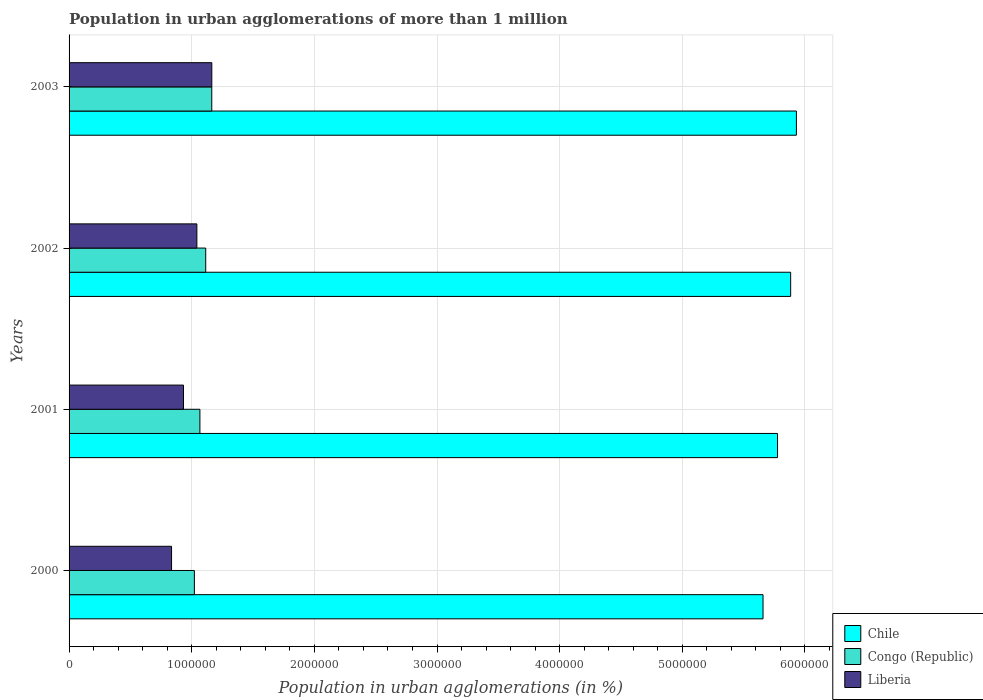How many different coloured bars are there?
Give a very brief answer. 3. Are the number of bars per tick equal to the number of legend labels?
Keep it short and to the point. Yes. Are the number of bars on each tick of the Y-axis equal?
Provide a succinct answer. Yes. How many bars are there on the 2nd tick from the bottom?
Your answer should be very brief. 3. In how many cases, is the number of bars for a given year not equal to the number of legend labels?
Keep it short and to the point. 0. What is the population in urban agglomerations in Congo (Republic) in 2003?
Offer a very short reply. 1.16e+06. Across all years, what is the maximum population in urban agglomerations in Chile?
Give a very brief answer. 5.93e+06. Across all years, what is the minimum population in urban agglomerations in Chile?
Provide a short and direct response. 5.66e+06. In which year was the population in urban agglomerations in Chile minimum?
Offer a terse response. 2000. What is the total population in urban agglomerations in Congo (Republic) in the graph?
Make the answer very short. 4.37e+06. What is the difference between the population in urban agglomerations in Chile in 2002 and that in 2003?
Provide a short and direct response. -4.69e+04. What is the difference between the population in urban agglomerations in Chile in 2000 and the population in urban agglomerations in Liberia in 2001?
Your answer should be very brief. 4.73e+06. What is the average population in urban agglomerations in Congo (Republic) per year?
Provide a succinct answer. 1.09e+06. In the year 2000, what is the difference between the population in urban agglomerations in Liberia and population in urban agglomerations in Congo (Republic)?
Your answer should be compact. -1.86e+05. In how many years, is the population in urban agglomerations in Congo (Republic) greater than 600000 %?
Your response must be concise. 4. What is the ratio of the population in urban agglomerations in Congo (Republic) in 2002 to that in 2003?
Make the answer very short. 0.96. Is the population in urban agglomerations in Congo (Republic) in 2000 less than that in 2001?
Offer a terse response. Yes. Is the difference between the population in urban agglomerations in Liberia in 2000 and 2001 greater than the difference between the population in urban agglomerations in Congo (Republic) in 2000 and 2001?
Offer a very short reply. No. What is the difference between the highest and the second highest population in urban agglomerations in Chile?
Your answer should be compact. 4.69e+04. What is the difference between the highest and the lowest population in urban agglomerations in Congo (Republic)?
Provide a succinct answer. 1.42e+05. Is the sum of the population in urban agglomerations in Liberia in 2001 and 2002 greater than the maximum population in urban agglomerations in Congo (Republic) across all years?
Provide a succinct answer. Yes. Is it the case that in every year, the sum of the population in urban agglomerations in Liberia and population in urban agglomerations in Chile is greater than the population in urban agglomerations in Congo (Republic)?
Provide a short and direct response. Yes. How many bars are there?
Provide a short and direct response. 12. Where does the legend appear in the graph?
Offer a very short reply. Bottom right. How are the legend labels stacked?
Make the answer very short. Vertical. What is the title of the graph?
Your answer should be compact. Population in urban agglomerations of more than 1 million. What is the label or title of the X-axis?
Your answer should be very brief. Population in urban agglomerations (in %). What is the Population in urban agglomerations (in %) of Chile in 2000?
Your answer should be compact. 5.66e+06. What is the Population in urban agglomerations (in %) in Congo (Republic) in 2000?
Give a very brief answer. 1.02e+06. What is the Population in urban agglomerations (in %) of Liberia in 2000?
Make the answer very short. 8.36e+05. What is the Population in urban agglomerations (in %) of Chile in 2001?
Give a very brief answer. 5.78e+06. What is the Population in urban agglomerations (in %) in Congo (Republic) in 2001?
Make the answer very short. 1.07e+06. What is the Population in urban agglomerations (in %) in Liberia in 2001?
Offer a terse response. 9.33e+05. What is the Population in urban agglomerations (in %) of Chile in 2002?
Provide a succinct answer. 5.88e+06. What is the Population in urban agglomerations (in %) in Congo (Republic) in 2002?
Your answer should be very brief. 1.11e+06. What is the Population in urban agglomerations (in %) in Liberia in 2002?
Make the answer very short. 1.04e+06. What is the Population in urban agglomerations (in %) in Chile in 2003?
Your answer should be compact. 5.93e+06. What is the Population in urban agglomerations (in %) in Congo (Republic) in 2003?
Your answer should be very brief. 1.16e+06. What is the Population in urban agglomerations (in %) in Liberia in 2003?
Make the answer very short. 1.16e+06. Across all years, what is the maximum Population in urban agglomerations (in %) in Chile?
Give a very brief answer. 5.93e+06. Across all years, what is the maximum Population in urban agglomerations (in %) in Congo (Republic)?
Provide a succinct answer. 1.16e+06. Across all years, what is the maximum Population in urban agglomerations (in %) in Liberia?
Provide a succinct answer. 1.16e+06. Across all years, what is the minimum Population in urban agglomerations (in %) of Chile?
Give a very brief answer. 5.66e+06. Across all years, what is the minimum Population in urban agglomerations (in %) of Congo (Republic)?
Keep it short and to the point. 1.02e+06. Across all years, what is the minimum Population in urban agglomerations (in %) in Liberia?
Provide a succinct answer. 8.36e+05. What is the total Population in urban agglomerations (in %) of Chile in the graph?
Offer a terse response. 2.32e+07. What is the total Population in urban agglomerations (in %) of Congo (Republic) in the graph?
Your response must be concise. 4.37e+06. What is the total Population in urban agglomerations (in %) of Liberia in the graph?
Ensure brevity in your answer.  3.97e+06. What is the difference between the Population in urban agglomerations (in %) in Chile in 2000 and that in 2001?
Your answer should be very brief. -1.18e+05. What is the difference between the Population in urban agglomerations (in %) of Congo (Republic) in 2000 and that in 2001?
Give a very brief answer. -4.52e+04. What is the difference between the Population in urban agglomerations (in %) in Liberia in 2000 and that in 2001?
Your answer should be very brief. -9.75e+04. What is the difference between the Population in urban agglomerations (in %) of Chile in 2000 and that in 2002?
Provide a succinct answer. -2.25e+05. What is the difference between the Population in urban agglomerations (in %) of Congo (Republic) in 2000 and that in 2002?
Provide a succinct answer. -9.25e+04. What is the difference between the Population in urban agglomerations (in %) in Liberia in 2000 and that in 2002?
Keep it short and to the point. -2.07e+05. What is the difference between the Population in urban agglomerations (in %) in Chile in 2000 and that in 2003?
Offer a very short reply. -2.72e+05. What is the difference between the Population in urban agglomerations (in %) in Congo (Republic) in 2000 and that in 2003?
Offer a very short reply. -1.42e+05. What is the difference between the Population in urban agglomerations (in %) of Liberia in 2000 and that in 2003?
Ensure brevity in your answer.  -3.28e+05. What is the difference between the Population in urban agglomerations (in %) in Chile in 2001 and that in 2002?
Offer a very short reply. -1.07e+05. What is the difference between the Population in urban agglomerations (in %) in Congo (Republic) in 2001 and that in 2002?
Ensure brevity in your answer.  -4.73e+04. What is the difference between the Population in urban agglomerations (in %) in Liberia in 2001 and that in 2002?
Your answer should be compact. -1.09e+05. What is the difference between the Population in urban agglomerations (in %) in Chile in 2001 and that in 2003?
Your response must be concise. -1.54e+05. What is the difference between the Population in urban agglomerations (in %) in Congo (Republic) in 2001 and that in 2003?
Provide a succinct answer. -9.67e+04. What is the difference between the Population in urban agglomerations (in %) of Liberia in 2001 and that in 2003?
Offer a very short reply. -2.31e+05. What is the difference between the Population in urban agglomerations (in %) of Chile in 2002 and that in 2003?
Keep it short and to the point. -4.69e+04. What is the difference between the Population in urban agglomerations (in %) of Congo (Republic) in 2002 and that in 2003?
Offer a terse response. -4.94e+04. What is the difference between the Population in urban agglomerations (in %) in Liberia in 2002 and that in 2003?
Your answer should be very brief. -1.22e+05. What is the difference between the Population in urban agglomerations (in %) of Chile in 2000 and the Population in urban agglomerations (in %) of Congo (Republic) in 2001?
Keep it short and to the point. 4.59e+06. What is the difference between the Population in urban agglomerations (in %) in Chile in 2000 and the Population in urban agglomerations (in %) in Liberia in 2001?
Your answer should be very brief. 4.73e+06. What is the difference between the Population in urban agglomerations (in %) in Congo (Republic) in 2000 and the Population in urban agglomerations (in %) in Liberia in 2001?
Offer a very short reply. 8.86e+04. What is the difference between the Population in urban agglomerations (in %) of Chile in 2000 and the Population in urban agglomerations (in %) of Congo (Republic) in 2002?
Offer a very short reply. 4.54e+06. What is the difference between the Population in urban agglomerations (in %) in Chile in 2000 and the Population in urban agglomerations (in %) in Liberia in 2002?
Your answer should be very brief. 4.62e+06. What is the difference between the Population in urban agglomerations (in %) of Congo (Republic) in 2000 and the Population in urban agglomerations (in %) of Liberia in 2002?
Offer a terse response. -2.04e+04. What is the difference between the Population in urban agglomerations (in %) of Chile in 2000 and the Population in urban agglomerations (in %) of Congo (Republic) in 2003?
Make the answer very short. 4.49e+06. What is the difference between the Population in urban agglomerations (in %) in Chile in 2000 and the Population in urban agglomerations (in %) in Liberia in 2003?
Give a very brief answer. 4.49e+06. What is the difference between the Population in urban agglomerations (in %) of Congo (Republic) in 2000 and the Population in urban agglomerations (in %) of Liberia in 2003?
Your response must be concise. -1.42e+05. What is the difference between the Population in urban agglomerations (in %) of Chile in 2001 and the Population in urban agglomerations (in %) of Congo (Republic) in 2002?
Provide a short and direct response. 4.66e+06. What is the difference between the Population in urban agglomerations (in %) of Chile in 2001 and the Population in urban agglomerations (in %) of Liberia in 2002?
Make the answer very short. 4.73e+06. What is the difference between the Population in urban agglomerations (in %) of Congo (Republic) in 2001 and the Population in urban agglomerations (in %) of Liberia in 2002?
Your answer should be very brief. 2.48e+04. What is the difference between the Population in urban agglomerations (in %) in Chile in 2001 and the Population in urban agglomerations (in %) in Congo (Republic) in 2003?
Make the answer very short. 4.61e+06. What is the difference between the Population in urban agglomerations (in %) of Chile in 2001 and the Population in urban agglomerations (in %) of Liberia in 2003?
Make the answer very short. 4.61e+06. What is the difference between the Population in urban agglomerations (in %) in Congo (Republic) in 2001 and the Population in urban agglomerations (in %) in Liberia in 2003?
Your answer should be very brief. -9.70e+04. What is the difference between the Population in urban agglomerations (in %) of Chile in 2002 and the Population in urban agglomerations (in %) of Congo (Republic) in 2003?
Provide a succinct answer. 4.72e+06. What is the difference between the Population in urban agglomerations (in %) in Chile in 2002 and the Population in urban agglomerations (in %) in Liberia in 2003?
Offer a very short reply. 4.72e+06. What is the difference between the Population in urban agglomerations (in %) of Congo (Republic) in 2002 and the Population in urban agglomerations (in %) of Liberia in 2003?
Offer a very short reply. -4.97e+04. What is the average Population in urban agglomerations (in %) of Chile per year?
Your answer should be very brief. 5.81e+06. What is the average Population in urban agglomerations (in %) of Congo (Republic) per year?
Your answer should be compact. 1.09e+06. What is the average Population in urban agglomerations (in %) of Liberia per year?
Give a very brief answer. 9.94e+05. In the year 2000, what is the difference between the Population in urban agglomerations (in %) of Chile and Population in urban agglomerations (in %) of Congo (Republic)?
Your answer should be compact. 4.64e+06. In the year 2000, what is the difference between the Population in urban agglomerations (in %) in Chile and Population in urban agglomerations (in %) in Liberia?
Your answer should be very brief. 4.82e+06. In the year 2000, what is the difference between the Population in urban agglomerations (in %) of Congo (Republic) and Population in urban agglomerations (in %) of Liberia?
Keep it short and to the point. 1.86e+05. In the year 2001, what is the difference between the Population in urban agglomerations (in %) of Chile and Population in urban agglomerations (in %) of Congo (Republic)?
Give a very brief answer. 4.71e+06. In the year 2001, what is the difference between the Population in urban agglomerations (in %) of Chile and Population in urban agglomerations (in %) of Liberia?
Offer a terse response. 4.84e+06. In the year 2001, what is the difference between the Population in urban agglomerations (in %) of Congo (Republic) and Population in urban agglomerations (in %) of Liberia?
Offer a terse response. 1.34e+05. In the year 2002, what is the difference between the Population in urban agglomerations (in %) of Chile and Population in urban agglomerations (in %) of Congo (Republic)?
Your answer should be very brief. 4.77e+06. In the year 2002, what is the difference between the Population in urban agglomerations (in %) of Chile and Population in urban agglomerations (in %) of Liberia?
Provide a short and direct response. 4.84e+06. In the year 2002, what is the difference between the Population in urban agglomerations (in %) of Congo (Republic) and Population in urban agglomerations (in %) of Liberia?
Ensure brevity in your answer.  7.21e+04. In the year 2003, what is the difference between the Population in urban agglomerations (in %) of Chile and Population in urban agglomerations (in %) of Congo (Republic)?
Give a very brief answer. 4.77e+06. In the year 2003, what is the difference between the Population in urban agglomerations (in %) in Chile and Population in urban agglomerations (in %) in Liberia?
Provide a short and direct response. 4.77e+06. In the year 2003, what is the difference between the Population in urban agglomerations (in %) in Congo (Republic) and Population in urban agglomerations (in %) in Liberia?
Offer a terse response. -312. What is the ratio of the Population in urban agglomerations (in %) in Chile in 2000 to that in 2001?
Your answer should be very brief. 0.98. What is the ratio of the Population in urban agglomerations (in %) in Congo (Republic) in 2000 to that in 2001?
Provide a succinct answer. 0.96. What is the ratio of the Population in urban agglomerations (in %) of Liberia in 2000 to that in 2001?
Offer a terse response. 0.9. What is the ratio of the Population in urban agglomerations (in %) in Chile in 2000 to that in 2002?
Give a very brief answer. 0.96. What is the ratio of the Population in urban agglomerations (in %) in Congo (Republic) in 2000 to that in 2002?
Your answer should be very brief. 0.92. What is the ratio of the Population in urban agglomerations (in %) in Liberia in 2000 to that in 2002?
Offer a very short reply. 0.8. What is the ratio of the Population in urban agglomerations (in %) of Chile in 2000 to that in 2003?
Your response must be concise. 0.95. What is the ratio of the Population in urban agglomerations (in %) in Congo (Republic) in 2000 to that in 2003?
Offer a very short reply. 0.88. What is the ratio of the Population in urban agglomerations (in %) of Liberia in 2000 to that in 2003?
Offer a very short reply. 0.72. What is the ratio of the Population in urban agglomerations (in %) of Chile in 2001 to that in 2002?
Give a very brief answer. 0.98. What is the ratio of the Population in urban agglomerations (in %) in Congo (Republic) in 2001 to that in 2002?
Offer a terse response. 0.96. What is the ratio of the Population in urban agglomerations (in %) of Liberia in 2001 to that in 2002?
Keep it short and to the point. 0.9. What is the ratio of the Population in urban agglomerations (in %) in Chile in 2001 to that in 2003?
Your answer should be compact. 0.97. What is the ratio of the Population in urban agglomerations (in %) in Congo (Republic) in 2001 to that in 2003?
Provide a short and direct response. 0.92. What is the ratio of the Population in urban agglomerations (in %) in Liberia in 2001 to that in 2003?
Your answer should be very brief. 0.8. What is the ratio of the Population in urban agglomerations (in %) in Chile in 2002 to that in 2003?
Ensure brevity in your answer.  0.99. What is the ratio of the Population in urban agglomerations (in %) in Congo (Republic) in 2002 to that in 2003?
Keep it short and to the point. 0.96. What is the ratio of the Population in urban agglomerations (in %) of Liberia in 2002 to that in 2003?
Your response must be concise. 0.9. What is the difference between the highest and the second highest Population in urban agglomerations (in %) of Chile?
Provide a short and direct response. 4.69e+04. What is the difference between the highest and the second highest Population in urban agglomerations (in %) in Congo (Republic)?
Your response must be concise. 4.94e+04. What is the difference between the highest and the second highest Population in urban agglomerations (in %) in Liberia?
Offer a terse response. 1.22e+05. What is the difference between the highest and the lowest Population in urban agglomerations (in %) in Chile?
Your answer should be very brief. 2.72e+05. What is the difference between the highest and the lowest Population in urban agglomerations (in %) in Congo (Republic)?
Your answer should be very brief. 1.42e+05. What is the difference between the highest and the lowest Population in urban agglomerations (in %) of Liberia?
Ensure brevity in your answer.  3.28e+05. 